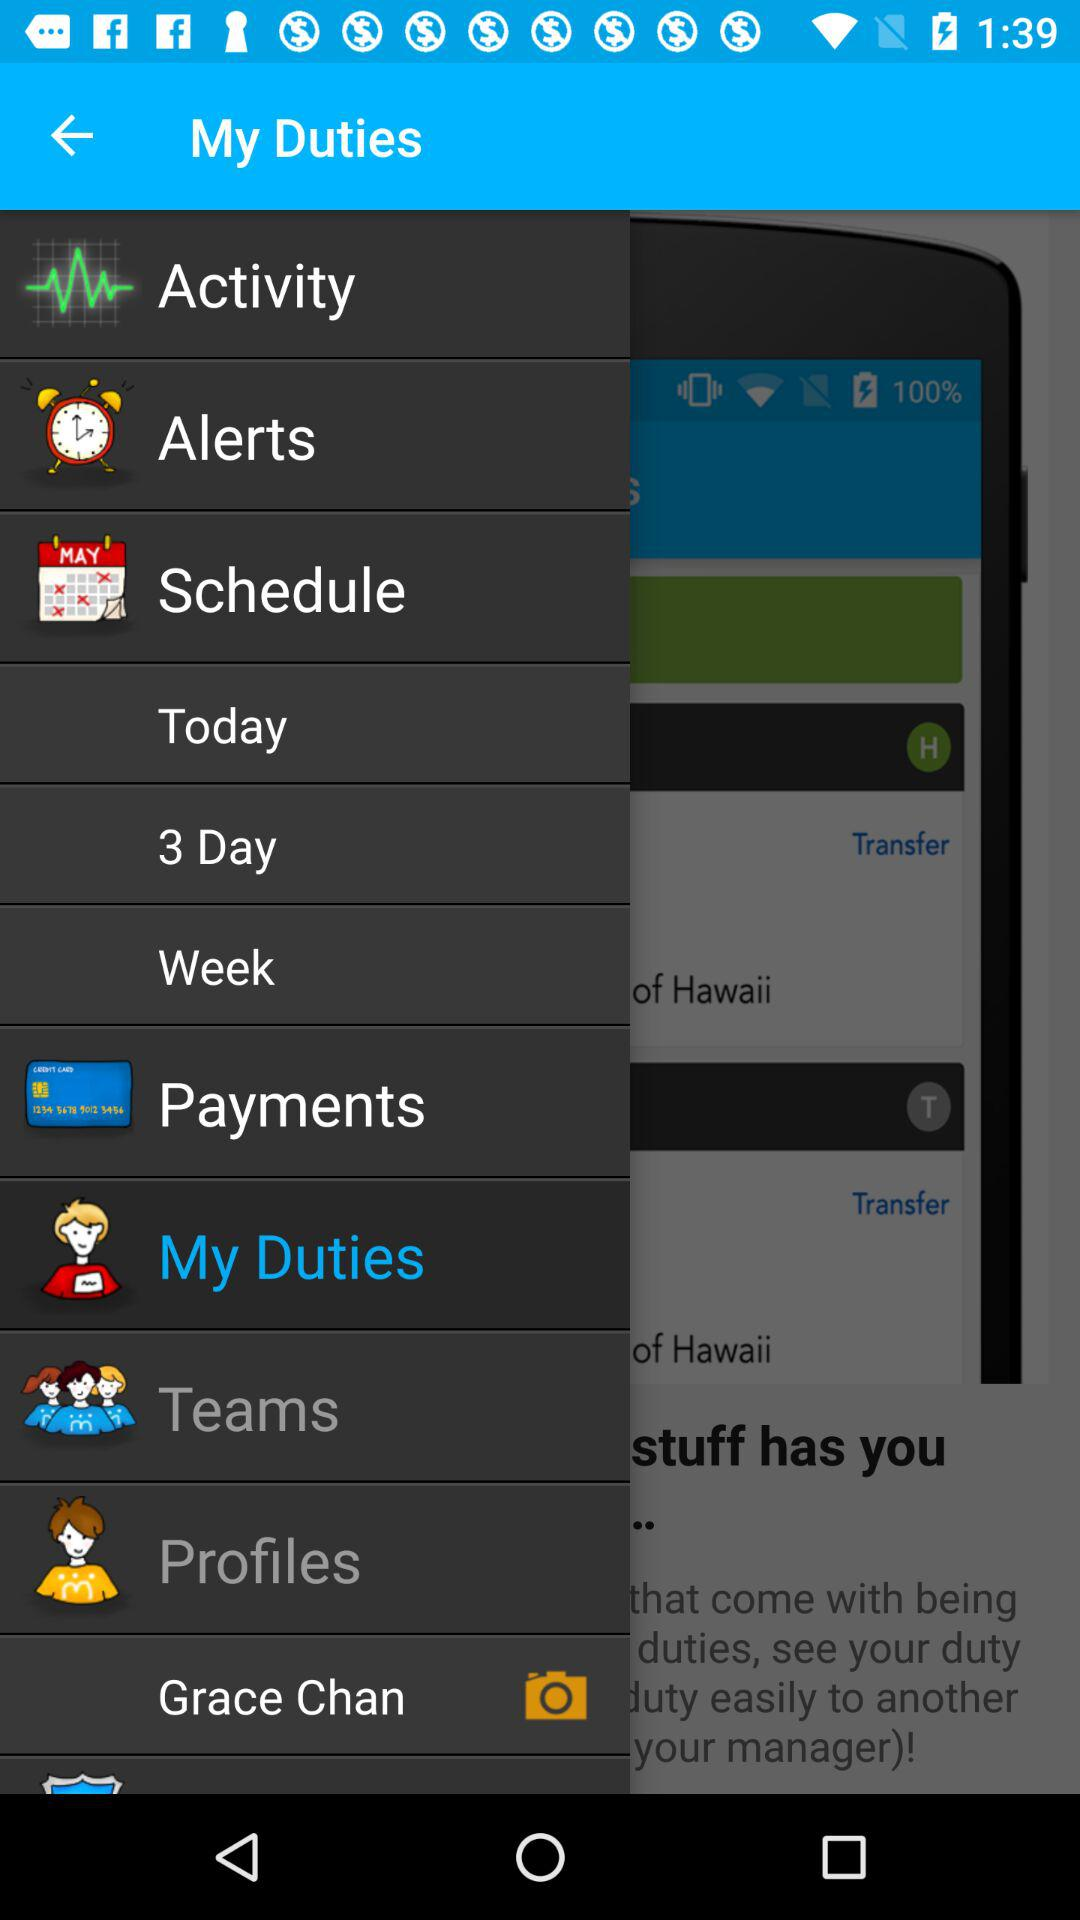What is the username? The username is Grace Chan. 